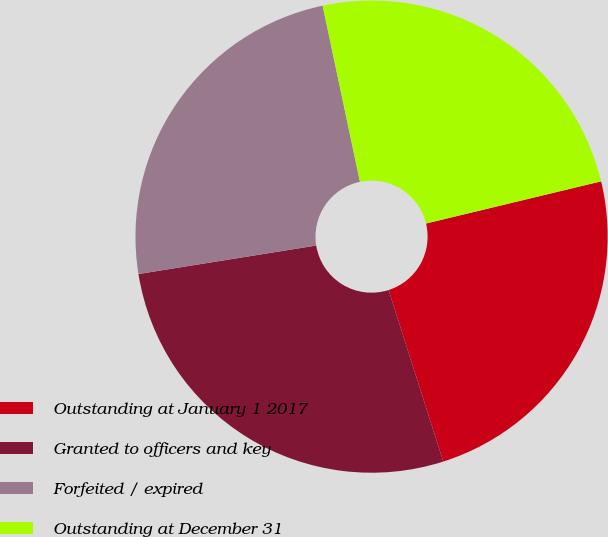Convert chart to OTSL. <chart><loc_0><loc_0><loc_500><loc_500><pie_chart><fcel>Outstanding at January 1 2017<fcel>Granted to officers and key<fcel>Forfeited / expired<fcel>Outstanding at December 31<nl><fcel>23.85%<fcel>27.38%<fcel>24.21%<fcel>24.56%<nl></chart> 